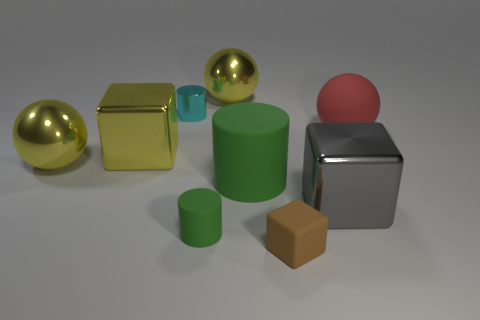Do the small green object and the big thing behind the cyan metal cylinder have the same shape?
Provide a short and direct response. No. There is a tiny object behind the big green cylinder; is it the same shape as the big red thing?
Offer a terse response. No. How many objects are both to the left of the large rubber sphere and right of the tiny metallic cylinder?
Give a very brief answer. 5. What number of other things are the same size as the red sphere?
Give a very brief answer. 5. Are there an equal number of large rubber things that are in front of the gray metallic block and big red matte balls?
Keep it short and to the point. No. Does the large block that is behind the gray metal block have the same color as the big metal thing behind the red matte sphere?
Your response must be concise. Yes. What is the material of the block that is both left of the big gray metallic cube and behind the small brown object?
Give a very brief answer. Metal. What color is the large rubber sphere?
Your answer should be very brief. Red. What number of other things are there of the same shape as the tiny cyan thing?
Offer a very short reply. 2. Is the number of spheres left of the big red rubber ball the same as the number of matte cylinders that are behind the large gray cube?
Give a very brief answer. No. 